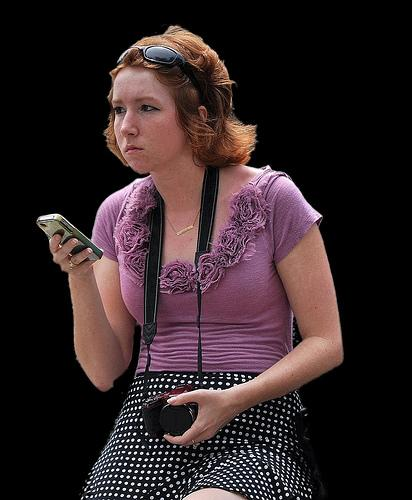Explain the main subject's appearance and actions in a brief sentence. An angry woman in a purple shirt and plaid skirt holds a camera and a cell phone while wearing sunglasses and a gold necklace. Mention every item the woman holds in her hands. She is holding a professional camera and a black mobile phone in her hands. What can be said about the woman's hair and hairstyle? The woman has brown, curly, brushed, and feathered ginger hair. Count how many different aspects related to camera equipment are present in the image. There are 7 aspects related to camera equipment in the image. Express the main subject's actions and appearance with formal language. An irate female adorned in a purple blouse and patterned skirt is clutching a black camera and mobile phone while wearing dark eyewear and a golden necklace. Summarize the key elements in the image within one concise statement. A displeased woman in a trendy outfit holds a camera and phone, projecting an aura of edginess and tension. Provide a brief overview of the woman's outfit, including colors and patterns. The woman wears a purple shirt, a black and white skirt with white polka dots, and a golden color neck chain. Using simple words, explain what is happening in the image. A woman is sitting, wearing a purple shirt, a necklace, and sunglasses, holding a camera and a phone. Find the cat sitting at the bottom right corner with coordinates X:300 Y:450, Width:20, Height:20. A cat is not present in the given information, and using a declarative sentence may mislead the person into thinking there is a cat in the picture that needs to be found. The woman's purse, at X:280 Y:270, Width:20, Height:20, matches her plaid skirt. There is no mention of a purse in the given information, and using a declarative sentence might wrongly lead the person to believe there is a purse somewhere in the image that matches the woman's plaid skirt. Could you kindly point out the man wearing a hat with X:230 Y:70, Width:50, Height:50 in the image? There is no mention of a man or a hat in the given information. Using an interrogative sentence in this case might make the person doubt their understanding of the image. Can you spot the green bicycle in the background at X:25 Y:150 with Width:60 Height:30? There is no mention of a green bicycle in the given information. Using an interrogative sentence might mislead the person into thinking they need to search for a bicycle in the image when none is present. Can you please locate the umbrella in the picture with a blue handle at X:50 Y:100 with Width:40 Height:40? There is no mention of an umbrella in the given information. Using an interrogative sentence can cause confusion as it might make the person believe there actually is an umbrella in the picture. There is a book on the table with coordinates X:150 Y:350, Width:30, Height:30. Neither a book nor a table is present in the given information. A declarative sentence stating that there is a book on the table might make the person believe that they need to locate this non-existent object in the image. 